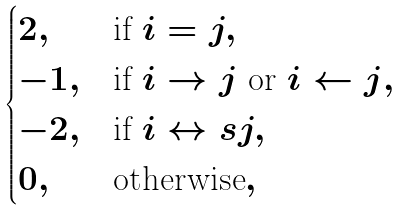<formula> <loc_0><loc_0><loc_500><loc_500>\begin{cases} 2 , & \text {if } i = j , \\ - 1 , & \text {if $i\rightarrow j$ or $i\leftarrow j$} , \\ - 2 , & \text {if } i \leftrightarrow s j , \\ 0 , & \text {otherwise} , \end{cases}</formula> 